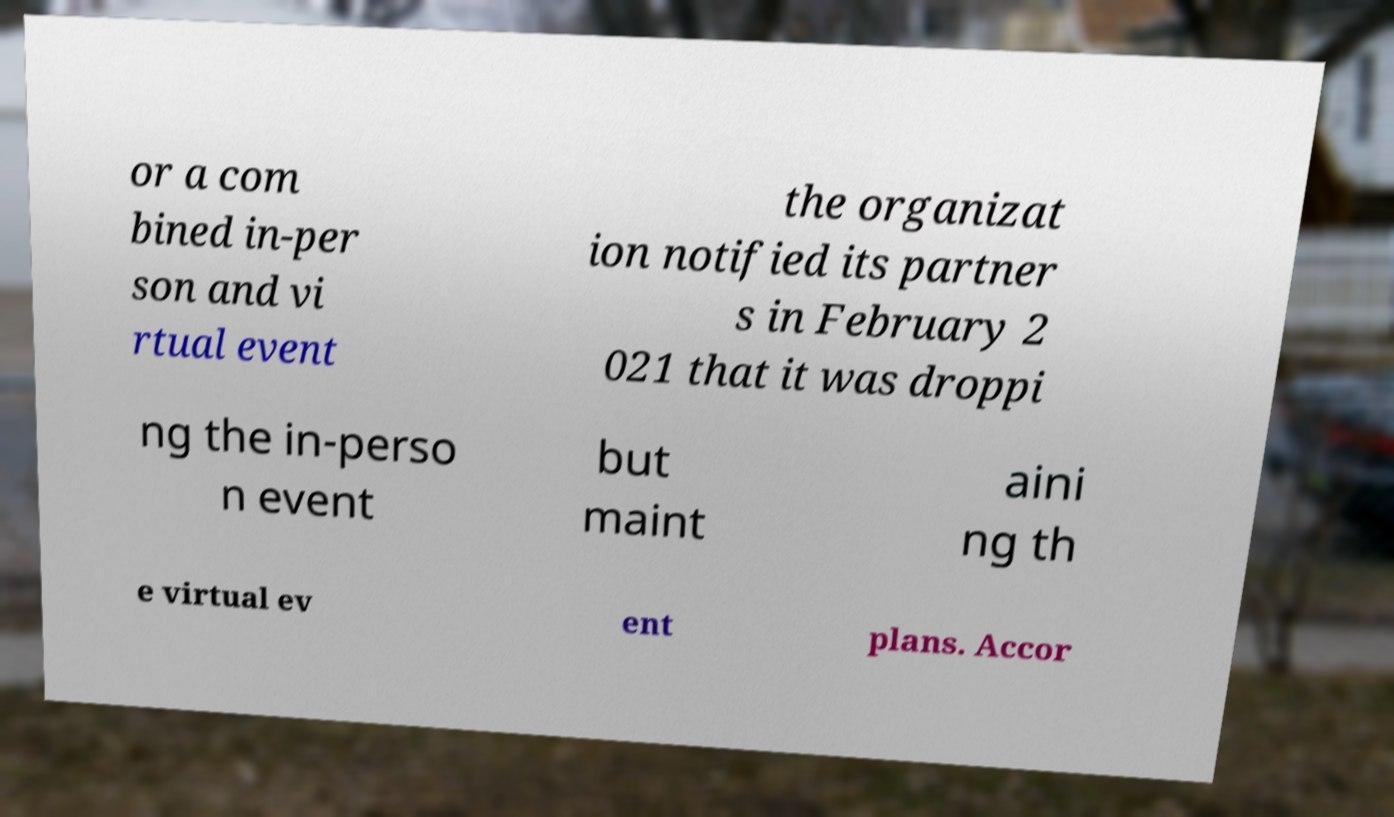For documentation purposes, I need the text within this image transcribed. Could you provide that? or a com bined in-per son and vi rtual event the organizat ion notified its partner s in February 2 021 that it was droppi ng the in-perso n event but maint aini ng th e virtual ev ent plans. Accor 